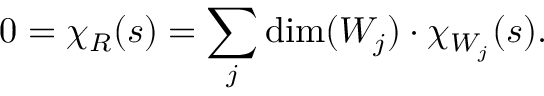Convert formula to latex. <formula><loc_0><loc_0><loc_500><loc_500>0 = \chi _ { R } ( s ) = \sum _ { j } \dim ( W _ { j } ) \cdot \chi _ { W _ { j } } ( s ) .</formula> 